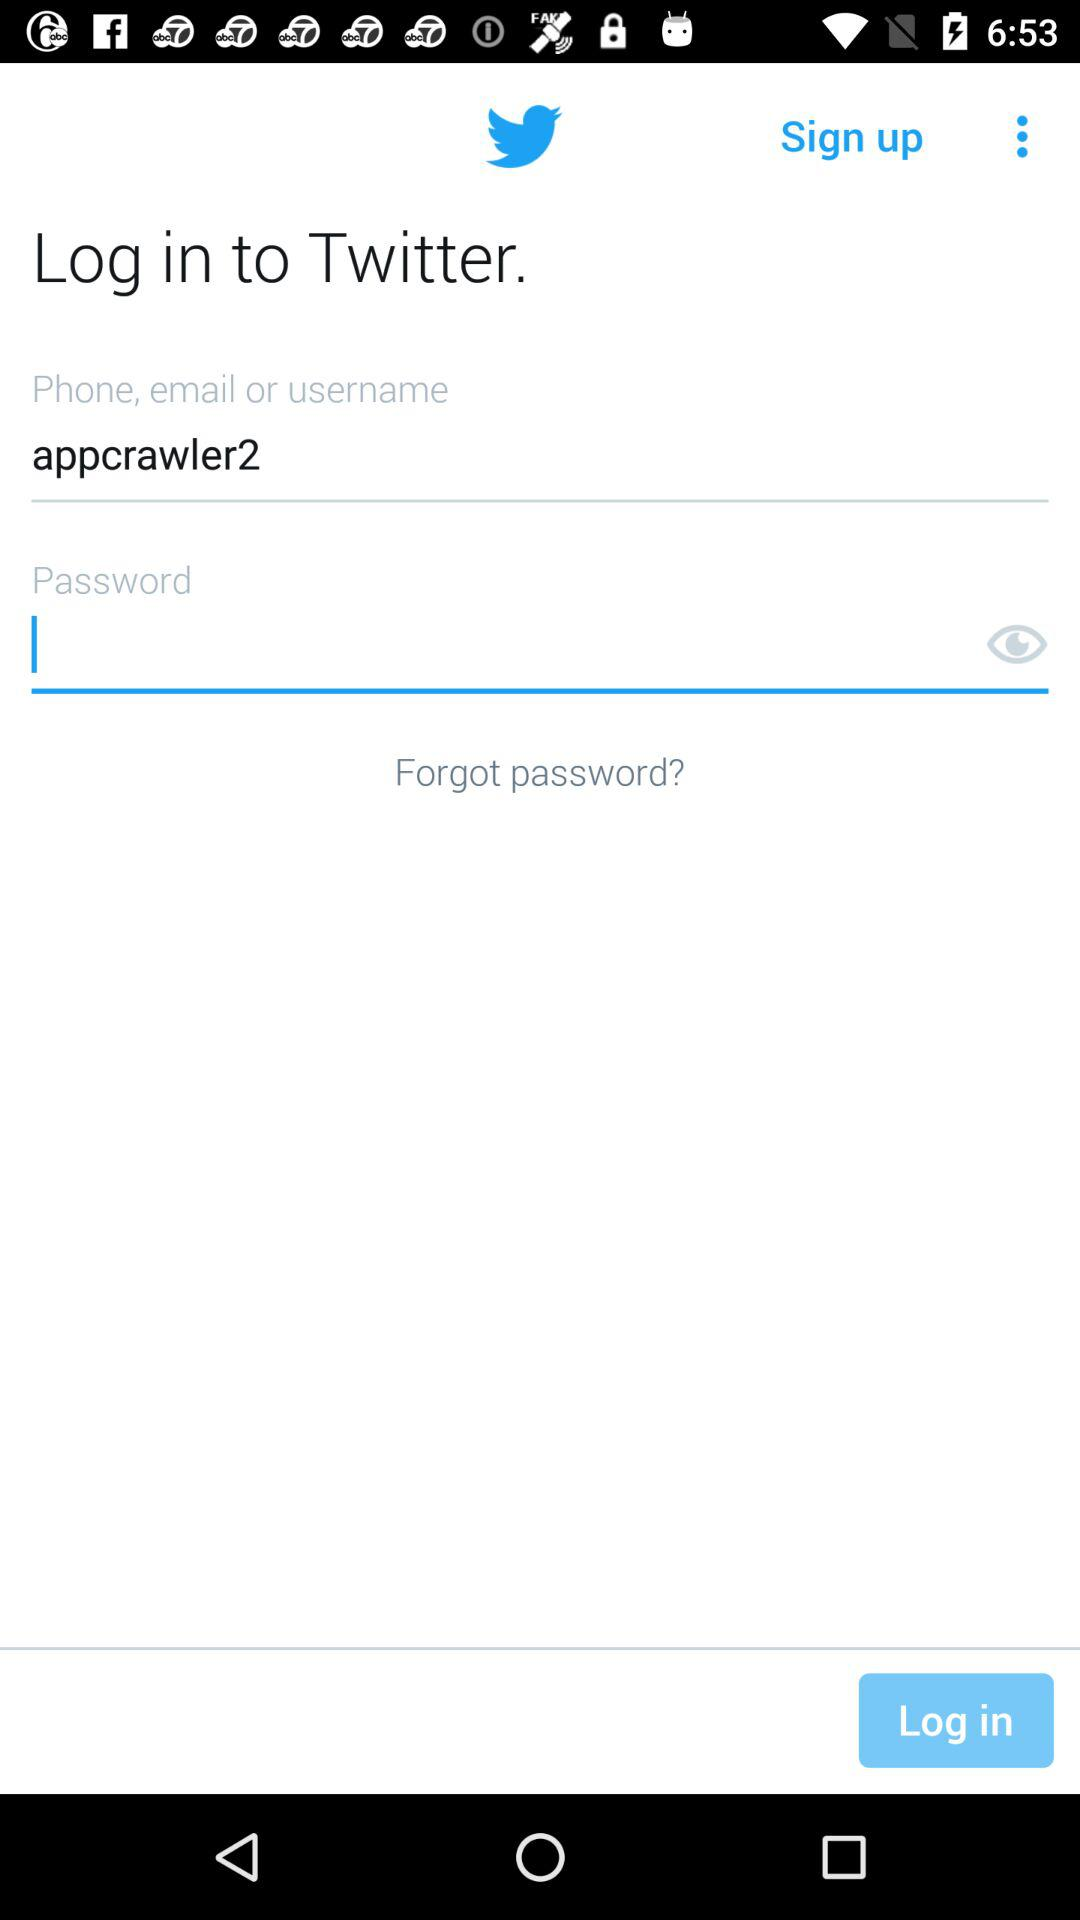What is the username? The username is appcrawler2. 